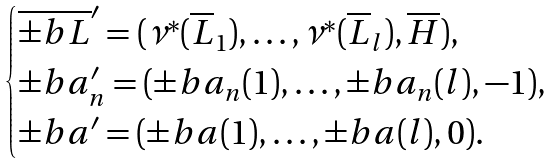Convert formula to latex. <formula><loc_0><loc_0><loc_500><loc_500>\begin{cases} \overline { \pm b { L } } ^ { \prime } = ( \nu ^ { * } ( \overline { L } _ { 1 } ) , \dots , \nu ^ { * } ( \overline { L } _ { l } ) , \overline { H } ) , \\ \pm b { a } ^ { \prime } _ { n } = ( \pm b { a } _ { n } ( 1 ) , \dots , \pm b { a } _ { n } ( l ) , - 1 ) , \\ \pm b { a } ^ { \prime } = ( \pm b { a } ( 1 ) , \dots , \pm b { a } ( l ) , 0 ) . \end{cases}</formula> 